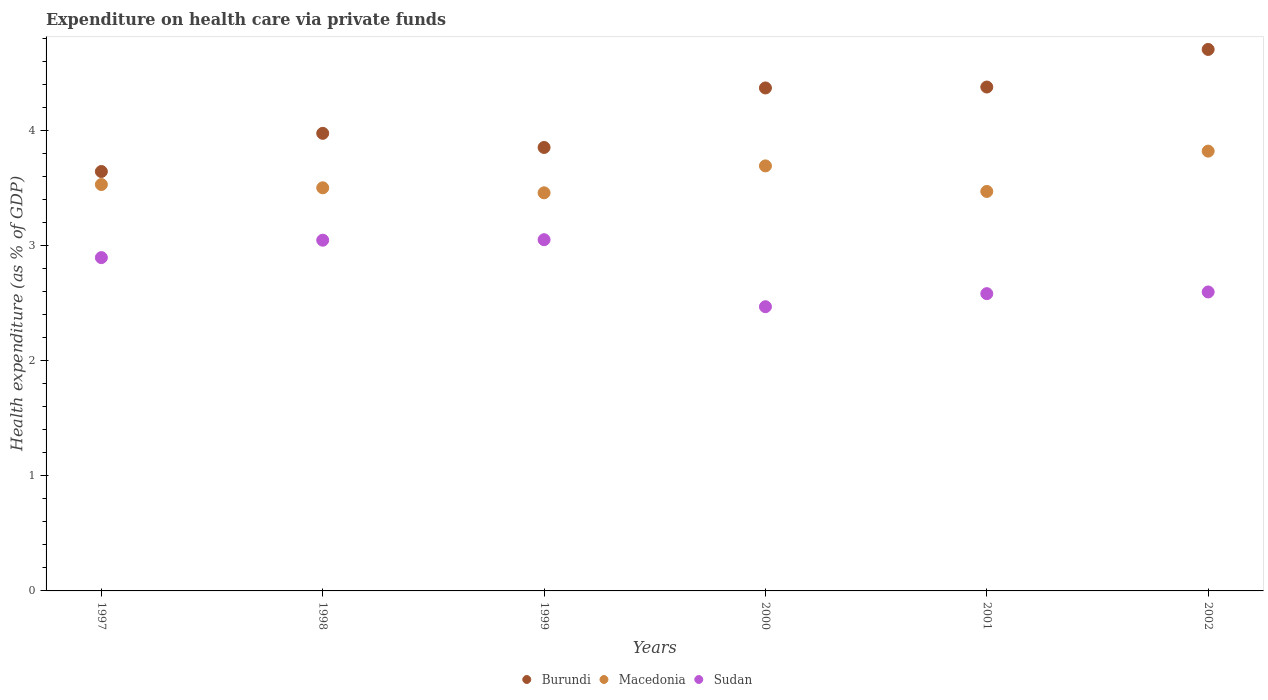How many different coloured dotlines are there?
Provide a succinct answer. 3. What is the expenditure made on health care in Burundi in 2001?
Keep it short and to the point. 4.38. Across all years, what is the maximum expenditure made on health care in Sudan?
Provide a short and direct response. 3.05. Across all years, what is the minimum expenditure made on health care in Sudan?
Your answer should be very brief. 2.47. What is the total expenditure made on health care in Burundi in the graph?
Offer a very short reply. 24.92. What is the difference between the expenditure made on health care in Burundi in 1998 and that in 2000?
Provide a short and direct response. -0.39. What is the difference between the expenditure made on health care in Burundi in 2002 and the expenditure made on health care in Sudan in 2001?
Provide a short and direct response. 2.12. What is the average expenditure made on health care in Burundi per year?
Keep it short and to the point. 4.15. In the year 1998, what is the difference between the expenditure made on health care in Burundi and expenditure made on health care in Sudan?
Keep it short and to the point. 0.93. What is the ratio of the expenditure made on health care in Sudan in 1998 to that in 2001?
Ensure brevity in your answer.  1.18. Is the difference between the expenditure made on health care in Burundi in 2000 and 2002 greater than the difference between the expenditure made on health care in Sudan in 2000 and 2002?
Offer a very short reply. No. What is the difference between the highest and the second highest expenditure made on health care in Macedonia?
Make the answer very short. 0.13. What is the difference between the highest and the lowest expenditure made on health care in Burundi?
Make the answer very short. 1.06. How many years are there in the graph?
Your answer should be compact. 6. Does the graph contain any zero values?
Provide a succinct answer. No. Does the graph contain grids?
Make the answer very short. No. Where does the legend appear in the graph?
Offer a very short reply. Bottom center. What is the title of the graph?
Keep it short and to the point. Expenditure on health care via private funds. Does "Zimbabwe" appear as one of the legend labels in the graph?
Offer a very short reply. No. What is the label or title of the Y-axis?
Your answer should be compact. Health expenditure (as % of GDP). What is the Health expenditure (as % of GDP) in Burundi in 1997?
Provide a succinct answer. 3.64. What is the Health expenditure (as % of GDP) of Macedonia in 1997?
Offer a terse response. 3.53. What is the Health expenditure (as % of GDP) in Sudan in 1997?
Make the answer very short. 2.9. What is the Health expenditure (as % of GDP) of Burundi in 1998?
Your answer should be compact. 3.97. What is the Health expenditure (as % of GDP) of Macedonia in 1998?
Your answer should be very brief. 3.5. What is the Health expenditure (as % of GDP) of Sudan in 1998?
Your response must be concise. 3.05. What is the Health expenditure (as % of GDP) of Burundi in 1999?
Your answer should be compact. 3.85. What is the Health expenditure (as % of GDP) in Macedonia in 1999?
Make the answer very short. 3.46. What is the Health expenditure (as % of GDP) of Sudan in 1999?
Give a very brief answer. 3.05. What is the Health expenditure (as % of GDP) in Burundi in 2000?
Offer a very short reply. 4.37. What is the Health expenditure (as % of GDP) in Macedonia in 2000?
Make the answer very short. 3.69. What is the Health expenditure (as % of GDP) in Sudan in 2000?
Offer a terse response. 2.47. What is the Health expenditure (as % of GDP) of Burundi in 2001?
Your answer should be very brief. 4.38. What is the Health expenditure (as % of GDP) of Macedonia in 2001?
Provide a short and direct response. 3.47. What is the Health expenditure (as % of GDP) of Sudan in 2001?
Provide a succinct answer. 2.58. What is the Health expenditure (as % of GDP) of Burundi in 2002?
Keep it short and to the point. 4.7. What is the Health expenditure (as % of GDP) of Macedonia in 2002?
Your answer should be very brief. 3.82. What is the Health expenditure (as % of GDP) in Sudan in 2002?
Keep it short and to the point. 2.6. Across all years, what is the maximum Health expenditure (as % of GDP) in Burundi?
Your response must be concise. 4.7. Across all years, what is the maximum Health expenditure (as % of GDP) of Macedonia?
Ensure brevity in your answer.  3.82. Across all years, what is the maximum Health expenditure (as % of GDP) of Sudan?
Offer a very short reply. 3.05. Across all years, what is the minimum Health expenditure (as % of GDP) of Burundi?
Provide a short and direct response. 3.64. Across all years, what is the minimum Health expenditure (as % of GDP) in Macedonia?
Keep it short and to the point. 3.46. Across all years, what is the minimum Health expenditure (as % of GDP) of Sudan?
Your answer should be very brief. 2.47. What is the total Health expenditure (as % of GDP) in Burundi in the graph?
Give a very brief answer. 24.92. What is the total Health expenditure (as % of GDP) of Macedonia in the graph?
Give a very brief answer. 21.47. What is the total Health expenditure (as % of GDP) in Sudan in the graph?
Your response must be concise. 16.64. What is the difference between the Health expenditure (as % of GDP) in Burundi in 1997 and that in 1998?
Offer a very short reply. -0.33. What is the difference between the Health expenditure (as % of GDP) of Macedonia in 1997 and that in 1998?
Your answer should be very brief. 0.03. What is the difference between the Health expenditure (as % of GDP) in Sudan in 1997 and that in 1998?
Your answer should be compact. -0.15. What is the difference between the Health expenditure (as % of GDP) of Burundi in 1997 and that in 1999?
Your answer should be compact. -0.21. What is the difference between the Health expenditure (as % of GDP) of Macedonia in 1997 and that in 1999?
Offer a terse response. 0.07. What is the difference between the Health expenditure (as % of GDP) in Sudan in 1997 and that in 1999?
Give a very brief answer. -0.16. What is the difference between the Health expenditure (as % of GDP) in Burundi in 1997 and that in 2000?
Provide a succinct answer. -0.73. What is the difference between the Health expenditure (as % of GDP) of Macedonia in 1997 and that in 2000?
Provide a short and direct response. -0.16. What is the difference between the Health expenditure (as % of GDP) of Sudan in 1997 and that in 2000?
Offer a terse response. 0.43. What is the difference between the Health expenditure (as % of GDP) in Burundi in 1997 and that in 2001?
Make the answer very short. -0.73. What is the difference between the Health expenditure (as % of GDP) in Macedonia in 1997 and that in 2001?
Your response must be concise. 0.06. What is the difference between the Health expenditure (as % of GDP) of Sudan in 1997 and that in 2001?
Give a very brief answer. 0.31. What is the difference between the Health expenditure (as % of GDP) in Burundi in 1997 and that in 2002?
Your answer should be very brief. -1.06. What is the difference between the Health expenditure (as % of GDP) of Macedonia in 1997 and that in 2002?
Provide a succinct answer. -0.29. What is the difference between the Health expenditure (as % of GDP) in Sudan in 1997 and that in 2002?
Your answer should be very brief. 0.3. What is the difference between the Health expenditure (as % of GDP) in Burundi in 1998 and that in 1999?
Your response must be concise. 0.12. What is the difference between the Health expenditure (as % of GDP) of Macedonia in 1998 and that in 1999?
Keep it short and to the point. 0.04. What is the difference between the Health expenditure (as % of GDP) of Sudan in 1998 and that in 1999?
Give a very brief answer. -0. What is the difference between the Health expenditure (as % of GDP) of Burundi in 1998 and that in 2000?
Keep it short and to the point. -0.39. What is the difference between the Health expenditure (as % of GDP) in Macedonia in 1998 and that in 2000?
Ensure brevity in your answer.  -0.19. What is the difference between the Health expenditure (as % of GDP) of Sudan in 1998 and that in 2000?
Offer a very short reply. 0.58. What is the difference between the Health expenditure (as % of GDP) of Burundi in 1998 and that in 2001?
Offer a very short reply. -0.4. What is the difference between the Health expenditure (as % of GDP) in Macedonia in 1998 and that in 2001?
Ensure brevity in your answer.  0.03. What is the difference between the Health expenditure (as % of GDP) of Sudan in 1998 and that in 2001?
Your answer should be very brief. 0.46. What is the difference between the Health expenditure (as % of GDP) in Burundi in 1998 and that in 2002?
Your answer should be compact. -0.73. What is the difference between the Health expenditure (as % of GDP) in Macedonia in 1998 and that in 2002?
Make the answer very short. -0.32. What is the difference between the Health expenditure (as % of GDP) in Sudan in 1998 and that in 2002?
Offer a terse response. 0.45. What is the difference between the Health expenditure (as % of GDP) in Burundi in 1999 and that in 2000?
Offer a very short reply. -0.52. What is the difference between the Health expenditure (as % of GDP) of Macedonia in 1999 and that in 2000?
Provide a succinct answer. -0.23. What is the difference between the Health expenditure (as % of GDP) in Sudan in 1999 and that in 2000?
Provide a short and direct response. 0.58. What is the difference between the Health expenditure (as % of GDP) in Burundi in 1999 and that in 2001?
Offer a terse response. -0.52. What is the difference between the Health expenditure (as % of GDP) of Macedonia in 1999 and that in 2001?
Give a very brief answer. -0.01. What is the difference between the Health expenditure (as % of GDP) in Sudan in 1999 and that in 2001?
Make the answer very short. 0.47. What is the difference between the Health expenditure (as % of GDP) in Burundi in 1999 and that in 2002?
Ensure brevity in your answer.  -0.85. What is the difference between the Health expenditure (as % of GDP) of Macedonia in 1999 and that in 2002?
Make the answer very short. -0.36. What is the difference between the Health expenditure (as % of GDP) in Sudan in 1999 and that in 2002?
Your response must be concise. 0.45. What is the difference between the Health expenditure (as % of GDP) in Burundi in 2000 and that in 2001?
Your answer should be compact. -0.01. What is the difference between the Health expenditure (as % of GDP) of Macedonia in 2000 and that in 2001?
Provide a succinct answer. 0.22. What is the difference between the Health expenditure (as % of GDP) of Sudan in 2000 and that in 2001?
Ensure brevity in your answer.  -0.11. What is the difference between the Health expenditure (as % of GDP) in Burundi in 2000 and that in 2002?
Keep it short and to the point. -0.33. What is the difference between the Health expenditure (as % of GDP) of Macedonia in 2000 and that in 2002?
Your answer should be compact. -0.13. What is the difference between the Health expenditure (as % of GDP) of Sudan in 2000 and that in 2002?
Your response must be concise. -0.13. What is the difference between the Health expenditure (as % of GDP) of Burundi in 2001 and that in 2002?
Ensure brevity in your answer.  -0.33. What is the difference between the Health expenditure (as % of GDP) of Macedonia in 2001 and that in 2002?
Your answer should be compact. -0.35. What is the difference between the Health expenditure (as % of GDP) in Sudan in 2001 and that in 2002?
Your answer should be very brief. -0.01. What is the difference between the Health expenditure (as % of GDP) in Burundi in 1997 and the Health expenditure (as % of GDP) in Macedonia in 1998?
Keep it short and to the point. 0.14. What is the difference between the Health expenditure (as % of GDP) in Burundi in 1997 and the Health expenditure (as % of GDP) in Sudan in 1998?
Your answer should be compact. 0.6. What is the difference between the Health expenditure (as % of GDP) in Macedonia in 1997 and the Health expenditure (as % of GDP) in Sudan in 1998?
Offer a terse response. 0.48. What is the difference between the Health expenditure (as % of GDP) of Burundi in 1997 and the Health expenditure (as % of GDP) of Macedonia in 1999?
Your response must be concise. 0.19. What is the difference between the Health expenditure (as % of GDP) in Burundi in 1997 and the Health expenditure (as % of GDP) in Sudan in 1999?
Ensure brevity in your answer.  0.59. What is the difference between the Health expenditure (as % of GDP) of Macedonia in 1997 and the Health expenditure (as % of GDP) of Sudan in 1999?
Provide a short and direct response. 0.48. What is the difference between the Health expenditure (as % of GDP) of Burundi in 1997 and the Health expenditure (as % of GDP) of Macedonia in 2000?
Make the answer very short. -0.05. What is the difference between the Health expenditure (as % of GDP) of Burundi in 1997 and the Health expenditure (as % of GDP) of Sudan in 2000?
Your response must be concise. 1.17. What is the difference between the Health expenditure (as % of GDP) in Macedonia in 1997 and the Health expenditure (as % of GDP) in Sudan in 2000?
Make the answer very short. 1.06. What is the difference between the Health expenditure (as % of GDP) of Burundi in 1997 and the Health expenditure (as % of GDP) of Macedonia in 2001?
Provide a succinct answer. 0.17. What is the difference between the Health expenditure (as % of GDP) of Burundi in 1997 and the Health expenditure (as % of GDP) of Sudan in 2001?
Your answer should be very brief. 1.06. What is the difference between the Health expenditure (as % of GDP) of Macedonia in 1997 and the Health expenditure (as % of GDP) of Sudan in 2001?
Make the answer very short. 0.95. What is the difference between the Health expenditure (as % of GDP) of Burundi in 1997 and the Health expenditure (as % of GDP) of Macedonia in 2002?
Your answer should be compact. -0.18. What is the difference between the Health expenditure (as % of GDP) in Burundi in 1997 and the Health expenditure (as % of GDP) in Sudan in 2002?
Your answer should be compact. 1.05. What is the difference between the Health expenditure (as % of GDP) of Macedonia in 1997 and the Health expenditure (as % of GDP) of Sudan in 2002?
Provide a succinct answer. 0.93. What is the difference between the Health expenditure (as % of GDP) of Burundi in 1998 and the Health expenditure (as % of GDP) of Macedonia in 1999?
Make the answer very short. 0.52. What is the difference between the Health expenditure (as % of GDP) of Burundi in 1998 and the Health expenditure (as % of GDP) of Sudan in 1999?
Provide a short and direct response. 0.92. What is the difference between the Health expenditure (as % of GDP) of Macedonia in 1998 and the Health expenditure (as % of GDP) of Sudan in 1999?
Provide a succinct answer. 0.45. What is the difference between the Health expenditure (as % of GDP) in Burundi in 1998 and the Health expenditure (as % of GDP) in Macedonia in 2000?
Ensure brevity in your answer.  0.28. What is the difference between the Health expenditure (as % of GDP) in Burundi in 1998 and the Health expenditure (as % of GDP) in Sudan in 2000?
Provide a succinct answer. 1.51. What is the difference between the Health expenditure (as % of GDP) in Macedonia in 1998 and the Health expenditure (as % of GDP) in Sudan in 2000?
Your response must be concise. 1.03. What is the difference between the Health expenditure (as % of GDP) of Burundi in 1998 and the Health expenditure (as % of GDP) of Macedonia in 2001?
Keep it short and to the point. 0.5. What is the difference between the Health expenditure (as % of GDP) in Burundi in 1998 and the Health expenditure (as % of GDP) in Sudan in 2001?
Your response must be concise. 1.39. What is the difference between the Health expenditure (as % of GDP) in Macedonia in 1998 and the Health expenditure (as % of GDP) in Sudan in 2001?
Provide a short and direct response. 0.92. What is the difference between the Health expenditure (as % of GDP) in Burundi in 1998 and the Health expenditure (as % of GDP) in Macedonia in 2002?
Your response must be concise. 0.15. What is the difference between the Health expenditure (as % of GDP) in Burundi in 1998 and the Health expenditure (as % of GDP) in Sudan in 2002?
Provide a short and direct response. 1.38. What is the difference between the Health expenditure (as % of GDP) in Macedonia in 1998 and the Health expenditure (as % of GDP) in Sudan in 2002?
Give a very brief answer. 0.9. What is the difference between the Health expenditure (as % of GDP) in Burundi in 1999 and the Health expenditure (as % of GDP) in Macedonia in 2000?
Offer a terse response. 0.16. What is the difference between the Health expenditure (as % of GDP) in Burundi in 1999 and the Health expenditure (as % of GDP) in Sudan in 2000?
Ensure brevity in your answer.  1.38. What is the difference between the Health expenditure (as % of GDP) of Macedonia in 1999 and the Health expenditure (as % of GDP) of Sudan in 2000?
Your answer should be very brief. 0.99. What is the difference between the Health expenditure (as % of GDP) of Burundi in 1999 and the Health expenditure (as % of GDP) of Macedonia in 2001?
Keep it short and to the point. 0.38. What is the difference between the Health expenditure (as % of GDP) of Burundi in 1999 and the Health expenditure (as % of GDP) of Sudan in 2001?
Provide a succinct answer. 1.27. What is the difference between the Health expenditure (as % of GDP) in Macedonia in 1999 and the Health expenditure (as % of GDP) in Sudan in 2001?
Give a very brief answer. 0.88. What is the difference between the Health expenditure (as % of GDP) of Burundi in 1999 and the Health expenditure (as % of GDP) of Macedonia in 2002?
Ensure brevity in your answer.  0.03. What is the difference between the Health expenditure (as % of GDP) of Burundi in 1999 and the Health expenditure (as % of GDP) of Sudan in 2002?
Your response must be concise. 1.26. What is the difference between the Health expenditure (as % of GDP) in Macedonia in 1999 and the Health expenditure (as % of GDP) in Sudan in 2002?
Offer a very short reply. 0.86. What is the difference between the Health expenditure (as % of GDP) in Burundi in 2000 and the Health expenditure (as % of GDP) in Macedonia in 2001?
Offer a terse response. 0.9. What is the difference between the Health expenditure (as % of GDP) of Burundi in 2000 and the Health expenditure (as % of GDP) of Sudan in 2001?
Provide a succinct answer. 1.79. What is the difference between the Health expenditure (as % of GDP) of Macedonia in 2000 and the Health expenditure (as % of GDP) of Sudan in 2001?
Provide a succinct answer. 1.11. What is the difference between the Health expenditure (as % of GDP) of Burundi in 2000 and the Health expenditure (as % of GDP) of Macedonia in 2002?
Ensure brevity in your answer.  0.55. What is the difference between the Health expenditure (as % of GDP) of Burundi in 2000 and the Health expenditure (as % of GDP) of Sudan in 2002?
Offer a terse response. 1.77. What is the difference between the Health expenditure (as % of GDP) of Macedonia in 2000 and the Health expenditure (as % of GDP) of Sudan in 2002?
Your answer should be very brief. 1.1. What is the difference between the Health expenditure (as % of GDP) of Burundi in 2001 and the Health expenditure (as % of GDP) of Macedonia in 2002?
Make the answer very short. 0.56. What is the difference between the Health expenditure (as % of GDP) in Burundi in 2001 and the Health expenditure (as % of GDP) in Sudan in 2002?
Make the answer very short. 1.78. What is the difference between the Health expenditure (as % of GDP) of Macedonia in 2001 and the Health expenditure (as % of GDP) of Sudan in 2002?
Your response must be concise. 0.87. What is the average Health expenditure (as % of GDP) of Burundi per year?
Give a very brief answer. 4.15. What is the average Health expenditure (as % of GDP) of Macedonia per year?
Offer a very short reply. 3.58. What is the average Health expenditure (as % of GDP) in Sudan per year?
Give a very brief answer. 2.77. In the year 1997, what is the difference between the Health expenditure (as % of GDP) of Burundi and Health expenditure (as % of GDP) of Macedonia?
Ensure brevity in your answer.  0.11. In the year 1997, what is the difference between the Health expenditure (as % of GDP) of Burundi and Health expenditure (as % of GDP) of Sudan?
Your answer should be very brief. 0.75. In the year 1997, what is the difference between the Health expenditure (as % of GDP) in Macedonia and Health expenditure (as % of GDP) in Sudan?
Provide a succinct answer. 0.63. In the year 1998, what is the difference between the Health expenditure (as % of GDP) in Burundi and Health expenditure (as % of GDP) in Macedonia?
Keep it short and to the point. 0.47. In the year 1998, what is the difference between the Health expenditure (as % of GDP) in Burundi and Health expenditure (as % of GDP) in Sudan?
Give a very brief answer. 0.93. In the year 1998, what is the difference between the Health expenditure (as % of GDP) of Macedonia and Health expenditure (as % of GDP) of Sudan?
Your response must be concise. 0.46. In the year 1999, what is the difference between the Health expenditure (as % of GDP) in Burundi and Health expenditure (as % of GDP) in Macedonia?
Give a very brief answer. 0.39. In the year 1999, what is the difference between the Health expenditure (as % of GDP) of Burundi and Health expenditure (as % of GDP) of Sudan?
Provide a succinct answer. 0.8. In the year 1999, what is the difference between the Health expenditure (as % of GDP) in Macedonia and Health expenditure (as % of GDP) in Sudan?
Give a very brief answer. 0.41. In the year 2000, what is the difference between the Health expenditure (as % of GDP) of Burundi and Health expenditure (as % of GDP) of Macedonia?
Your answer should be very brief. 0.68. In the year 2000, what is the difference between the Health expenditure (as % of GDP) in Burundi and Health expenditure (as % of GDP) in Sudan?
Your response must be concise. 1.9. In the year 2000, what is the difference between the Health expenditure (as % of GDP) in Macedonia and Health expenditure (as % of GDP) in Sudan?
Your answer should be very brief. 1.22. In the year 2001, what is the difference between the Health expenditure (as % of GDP) of Burundi and Health expenditure (as % of GDP) of Macedonia?
Your answer should be very brief. 0.91. In the year 2001, what is the difference between the Health expenditure (as % of GDP) in Burundi and Health expenditure (as % of GDP) in Sudan?
Provide a short and direct response. 1.79. In the year 2001, what is the difference between the Health expenditure (as % of GDP) of Macedonia and Health expenditure (as % of GDP) of Sudan?
Keep it short and to the point. 0.89. In the year 2002, what is the difference between the Health expenditure (as % of GDP) in Burundi and Health expenditure (as % of GDP) in Macedonia?
Keep it short and to the point. 0.88. In the year 2002, what is the difference between the Health expenditure (as % of GDP) of Burundi and Health expenditure (as % of GDP) of Sudan?
Your answer should be compact. 2.11. In the year 2002, what is the difference between the Health expenditure (as % of GDP) of Macedonia and Health expenditure (as % of GDP) of Sudan?
Your response must be concise. 1.22. What is the ratio of the Health expenditure (as % of GDP) in Burundi in 1997 to that in 1998?
Ensure brevity in your answer.  0.92. What is the ratio of the Health expenditure (as % of GDP) of Sudan in 1997 to that in 1998?
Keep it short and to the point. 0.95. What is the ratio of the Health expenditure (as % of GDP) in Burundi in 1997 to that in 1999?
Your answer should be compact. 0.95. What is the ratio of the Health expenditure (as % of GDP) in Macedonia in 1997 to that in 1999?
Provide a succinct answer. 1.02. What is the ratio of the Health expenditure (as % of GDP) of Sudan in 1997 to that in 1999?
Give a very brief answer. 0.95. What is the ratio of the Health expenditure (as % of GDP) in Burundi in 1997 to that in 2000?
Your response must be concise. 0.83. What is the ratio of the Health expenditure (as % of GDP) in Macedonia in 1997 to that in 2000?
Ensure brevity in your answer.  0.96. What is the ratio of the Health expenditure (as % of GDP) of Sudan in 1997 to that in 2000?
Make the answer very short. 1.17. What is the ratio of the Health expenditure (as % of GDP) in Burundi in 1997 to that in 2001?
Offer a terse response. 0.83. What is the ratio of the Health expenditure (as % of GDP) of Macedonia in 1997 to that in 2001?
Give a very brief answer. 1.02. What is the ratio of the Health expenditure (as % of GDP) of Sudan in 1997 to that in 2001?
Offer a very short reply. 1.12. What is the ratio of the Health expenditure (as % of GDP) of Burundi in 1997 to that in 2002?
Offer a terse response. 0.77. What is the ratio of the Health expenditure (as % of GDP) in Macedonia in 1997 to that in 2002?
Give a very brief answer. 0.92. What is the ratio of the Health expenditure (as % of GDP) of Sudan in 1997 to that in 2002?
Make the answer very short. 1.11. What is the ratio of the Health expenditure (as % of GDP) in Burundi in 1998 to that in 1999?
Provide a succinct answer. 1.03. What is the ratio of the Health expenditure (as % of GDP) of Macedonia in 1998 to that in 1999?
Make the answer very short. 1.01. What is the ratio of the Health expenditure (as % of GDP) in Sudan in 1998 to that in 1999?
Your answer should be very brief. 1. What is the ratio of the Health expenditure (as % of GDP) of Burundi in 1998 to that in 2000?
Provide a succinct answer. 0.91. What is the ratio of the Health expenditure (as % of GDP) of Macedonia in 1998 to that in 2000?
Ensure brevity in your answer.  0.95. What is the ratio of the Health expenditure (as % of GDP) of Sudan in 1998 to that in 2000?
Offer a very short reply. 1.23. What is the ratio of the Health expenditure (as % of GDP) of Burundi in 1998 to that in 2001?
Your answer should be very brief. 0.91. What is the ratio of the Health expenditure (as % of GDP) in Macedonia in 1998 to that in 2001?
Offer a terse response. 1.01. What is the ratio of the Health expenditure (as % of GDP) of Sudan in 1998 to that in 2001?
Your response must be concise. 1.18. What is the ratio of the Health expenditure (as % of GDP) in Burundi in 1998 to that in 2002?
Make the answer very short. 0.84. What is the ratio of the Health expenditure (as % of GDP) in Macedonia in 1998 to that in 2002?
Provide a succinct answer. 0.92. What is the ratio of the Health expenditure (as % of GDP) in Sudan in 1998 to that in 2002?
Your answer should be very brief. 1.17. What is the ratio of the Health expenditure (as % of GDP) of Burundi in 1999 to that in 2000?
Provide a short and direct response. 0.88. What is the ratio of the Health expenditure (as % of GDP) in Macedonia in 1999 to that in 2000?
Offer a very short reply. 0.94. What is the ratio of the Health expenditure (as % of GDP) in Sudan in 1999 to that in 2000?
Offer a very short reply. 1.24. What is the ratio of the Health expenditure (as % of GDP) of Burundi in 1999 to that in 2001?
Offer a terse response. 0.88. What is the ratio of the Health expenditure (as % of GDP) in Sudan in 1999 to that in 2001?
Provide a succinct answer. 1.18. What is the ratio of the Health expenditure (as % of GDP) in Burundi in 1999 to that in 2002?
Offer a very short reply. 0.82. What is the ratio of the Health expenditure (as % of GDP) of Macedonia in 1999 to that in 2002?
Your response must be concise. 0.91. What is the ratio of the Health expenditure (as % of GDP) in Sudan in 1999 to that in 2002?
Keep it short and to the point. 1.17. What is the ratio of the Health expenditure (as % of GDP) of Burundi in 2000 to that in 2001?
Keep it short and to the point. 1. What is the ratio of the Health expenditure (as % of GDP) of Macedonia in 2000 to that in 2001?
Your response must be concise. 1.06. What is the ratio of the Health expenditure (as % of GDP) of Sudan in 2000 to that in 2001?
Your answer should be very brief. 0.96. What is the ratio of the Health expenditure (as % of GDP) of Burundi in 2000 to that in 2002?
Ensure brevity in your answer.  0.93. What is the ratio of the Health expenditure (as % of GDP) in Macedonia in 2000 to that in 2002?
Ensure brevity in your answer.  0.97. What is the ratio of the Health expenditure (as % of GDP) in Sudan in 2000 to that in 2002?
Give a very brief answer. 0.95. What is the ratio of the Health expenditure (as % of GDP) of Burundi in 2001 to that in 2002?
Offer a very short reply. 0.93. What is the ratio of the Health expenditure (as % of GDP) in Macedonia in 2001 to that in 2002?
Your answer should be compact. 0.91. What is the ratio of the Health expenditure (as % of GDP) of Sudan in 2001 to that in 2002?
Provide a short and direct response. 0.99. What is the difference between the highest and the second highest Health expenditure (as % of GDP) in Burundi?
Keep it short and to the point. 0.33. What is the difference between the highest and the second highest Health expenditure (as % of GDP) in Macedonia?
Your answer should be compact. 0.13. What is the difference between the highest and the second highest Health expenditure (as % of GDP) of Sudan?
Offer a very short reply. 0. What is the difference between the highest and the lowest Health expenditure (as % of GDP) of Burundi?
Offer a very short reply. 1.06. What is the difference between the highest and the lowest Health expenditure (as % of GDP) in Macedonia?
Give a very brief answer. 0.36. What is the difference between the highest and the lowest Health expenditure (as % of GDP) of Sudan?
Your answer should be very brief. 0.58. 